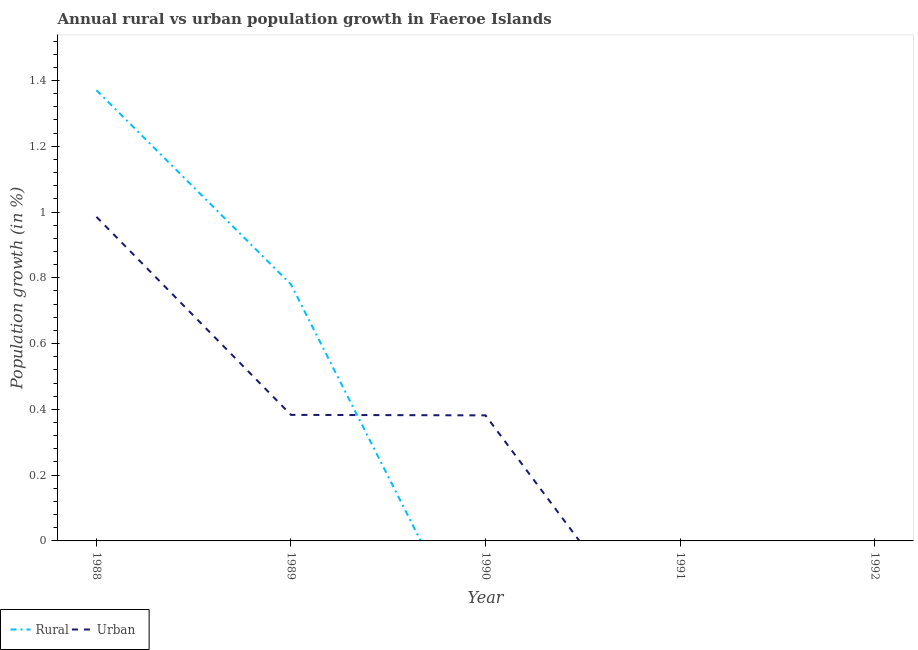How many different coloured lines are there?
Your response must be concise. 2. Is the number of lines equal to the number of legend labels?
Your answer should be compact. No. What is the rural population growth in 1988?
Provide a short and direct response. 1.37. Across all years, what is the maximum rural population growth?
Provide a short and direct response. 1.37. What is the total urban population growth in the graph?
Your answer should be very brief. 1.75. What is the difference between the urban population growth in 1989 and that in 1990?
Make the answer very short. 0. What is the difference between the urban population growth in 1991 and the rural population growth in 1992?
Give a very brief answer. 0. What is the average urban population growth per year?
Provide a short and direct response. 0.35. In the year 1988, what is the difference between the rural population growth and urban population growth?
Offer a terse response. 0.39. Is the difference between the rural population growth in 1988 and 1989 greater than the difference between the urban population growth in 1988 and 1989?
Offer a very short reply. No. What is the difference between the highest and the second highest urban population growth?
Your answer should be compact. 0.6. What is the difference between the highest and the lowest urban population growth?
Your response must be concise. 0.99. In how many years, is the urban population growth greater than the average urban population growth taken over all years?
Your answer should be very brief. 3. Does the rural population growth monotonically increase over the years?
Ensure brevity in your answer.  No. Is the urban population growth strictly less than the rural population growth over the years?
Ensure brevity in your answer.  No. Are the values on the major ticks of Y-axis written in scientific E-notation?
Ensure brevity in your answer.  No. Where does the legend appear in the graph?
Offer a very short reply. Bottom left. How many legend labels are there?
Your answer should be compact. 2. What is the title of the graph?
Your response must be concise. Annual rural vs urban population growth in Faeroe Islands. Does "Primary income" appear as one of the legend labels in the graph?
Make the answer very short. No. What is the label or title of the X-axis?
Give a very brief answer. Year. What is the label or title of the Y-axis?
Ensure brevity in your answer.  Population growth (in %). What is the Population growth (in %) of Rural in 1988?
Your answer should be very brief. 1.37. What is the Population growth (in %) in Urban  in 1988?
Your answer should be compact. 0.99. What is the Population growth (in %) in Rural in 1989?
Give a very brief answer. 0.78. What is the Population growth (in %) in Urban  in 1989?
Provide a short and direct response. 0.38. What is the Population growth (in %) in Urban  in 1990?
Ensure brevity in your answer.  0.38. What is the Population growth (in %) of Urban  in 1991?
Your answer should be very brief. 0. Across all years, what is the maximum Population growth (in %) in Rural?
Make the answer very short. 1.37. Across all years, what is the maximum Population growth (in %) of Urban ?
Offer a very short reply. 0.99. Across all years, what is the minimum Population growth (in %) in Urban ?
Your response must be concise. 0. What is the total Population growth (in %) in Rural in the graph?
Offer a terse response. 2.15. What is the total Population growth (in %) of Urban  in the graph?
Offer a terse response. 1.75. What is the difference between the Population growth (in %) in Rural in 1988 and that in 1989?
Your answer should be compact. 0.59. What is the difference between the Population growth (in %) in Urban  in 1988 and that in 1989?
Provide a short and direct response. 0.6. What is the difference between the Population growth (in %) in Urban  in 1988 and that in 1990?
Offer a terse response. 0.6. What is the difference between the Population growth (in %) in Urban  in 1989 and that in 1990?
Make the answer very short. 0. What is the difference between the Population growth (in %) in Rural in 1988 and the Population growth (in %) in Urban  in 1989?
Offer a very short reply. 0.99. What is the difference between the Population growth (in %) of Rural in 1988 and the Population growth (in %) of Urban  in 1990?
Provide a succinct answer. 0.99. What is the difference between the Population growth (in %) in Rural in 1989 and the Population growth (in %) in Urban  in 1990?
Give a very brief answer. 0.4. What is the average Population growth (in %) of Rural per year?
Give a very brief answer. 0.43. What is the average Population growth (in %) in Urban  per year?
Your answer should be very brief. 0.35. In the year 1988, what is the difference between the Population growth (in %) in Rural and Population growth (in %) in Urban ?
Provide a succinct answer. 0.39. In the year 1989, what is the difference between the Population growth (in %) of Rural and Population growth (in %) of Urban ?
Your answer should be compact. 0.4. What is the ratio of the Population growth (in %) in Rural in 1988 to that in 1989?
Offer a terse response. 1.76. What is the ratio of the Population growth (in %) in Urban  in 1988 to that in 1989?
Your answer should be very brief. 2.57. What is the ratio of the Population growth (in %) in Urban  in 1988 to that in 1990?
Offer a very short reply. 2.58. What is the difference between the highest and the second highest Population growth (in %) of Urban ?
Provide a short and direct response. 0.6. What is the difference between the highest and the lowest Population growth (in %) in Rural?
Offer a terse response. 1.37. What is the difference between the highest and the lowest Population growth (in %) of Urban ?
Provide a short and direct response. 0.99. 